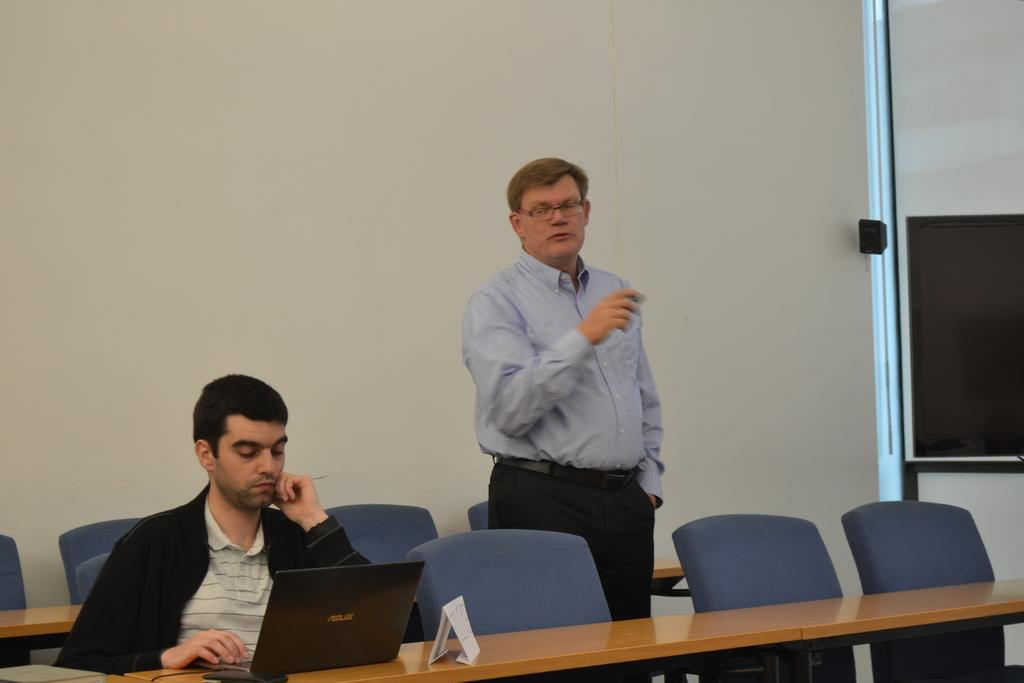What is the man in the image doing? The man standing in the image has a laptop in front of him. Who else is present in the image? There is a person sitting in the image. What is the position of the man in relation to the chairs? There are empty chairs beside the man. What can be seen in the background of the image? There is a white wall in the background. What type of destruction is the worm causing in the image? There is no worm present in the image, and therefore no destruction can be observed. 